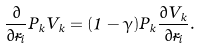Convert formula to latex. <formula><loc_0><loc_0><loc_500><loc_500>\frac { \partial } { \partial \vec { r } _ { i } } P _ { k } V _ { k } = ( 1 - \gamma ) P _ { k } \frac { \partial V _ { k } } { \partial \vec { r } _ { i } } .</formula> 